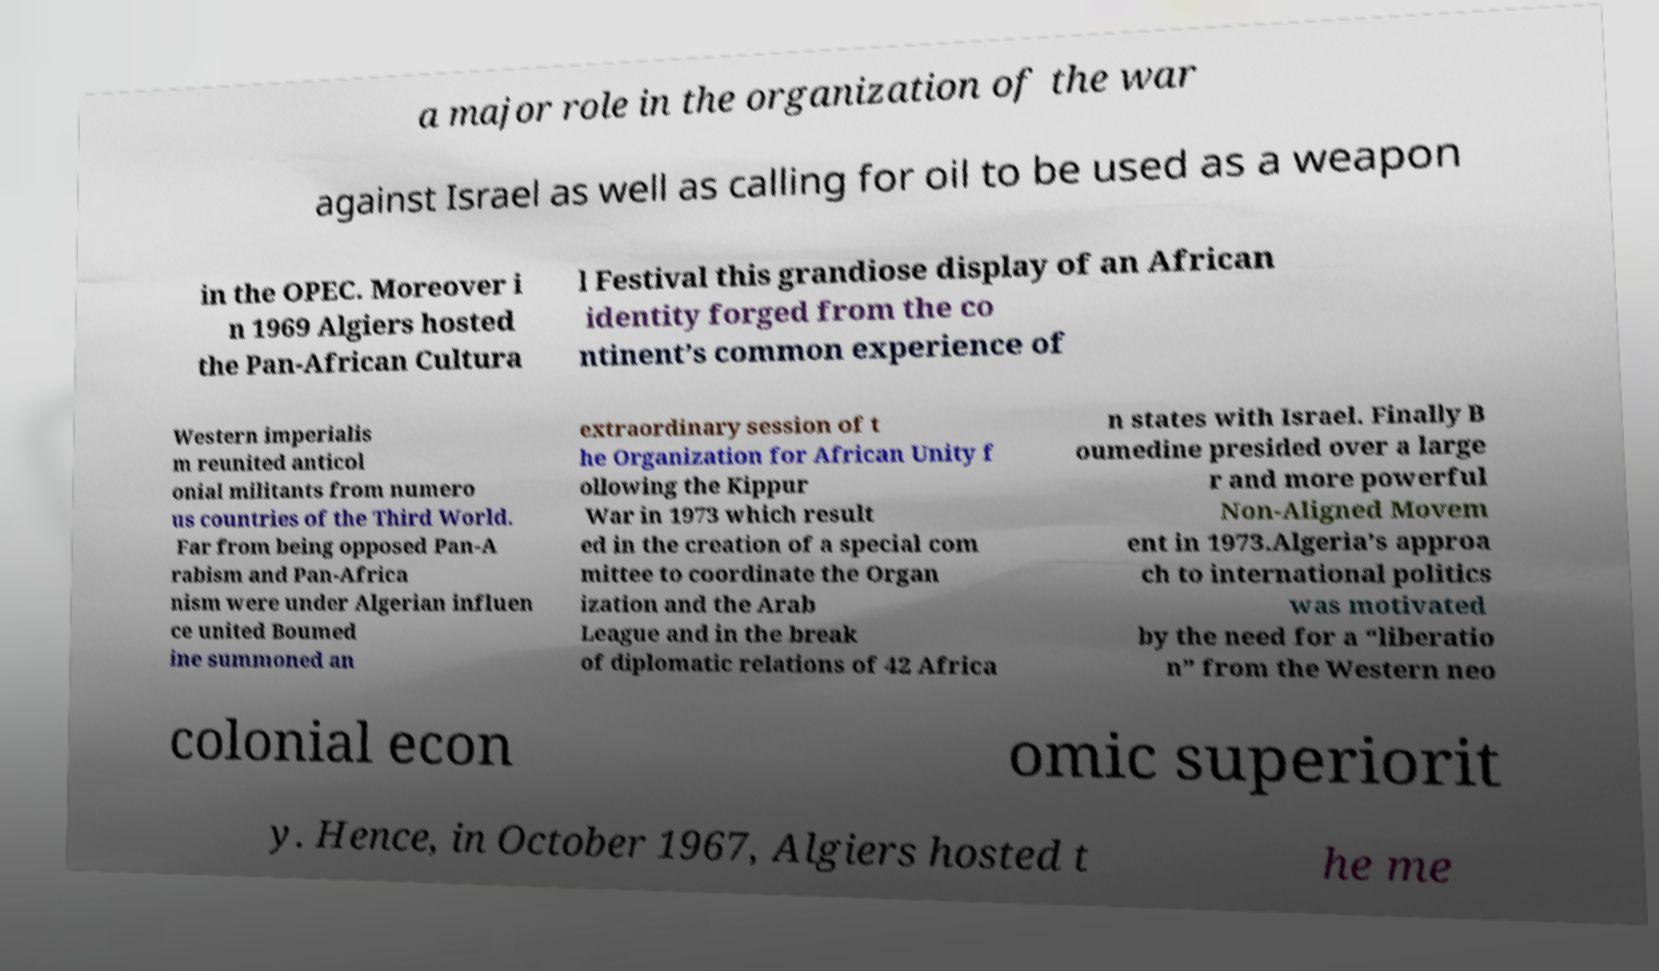There's text embedded in this image that I need extracted. Can you transcribe it verbatim? a major role in the organization of the war against Israel as well as calling for oil to be used as a weapon in the OPEC. Moreover i n 1969 Algiers hosted the Pan-African Cultura l Festival this grandiose display of an African identity forged from the co ntinent’s common experience of Western imperialis m reunited anticol onial militants from numero us countries of the Third World. Far from being opposed Pan-A rabism and Pan-Africa nism were under Algerian influen ce united Boumed ine summoned an extraordinary session of t he Organization for African Unity f ollowing the Kippur War in 1973 which result ed in the creation of a special com mittee to coordinate the Organ ization and the Arab League and in the break of diplomatic relations of 42 Africa n states with Israel. Finally B oumedine presided over a large r and more powerful Non-Aligned Movem ent in 1973.Algeria’s approa ch to international politics was motivated by the need for a “liberatio n” from the Western neo colonial econ omic superiorit y. Hence, in October 1967, Algiers hosted t he me 